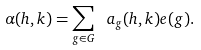<formula> <loc_0><loc_0><loc_500><loc_500>\alpha ( h , k ) = \sum _ { g \in G } \ a _ { g } ( h , k ) e ( g ) .</formula> 